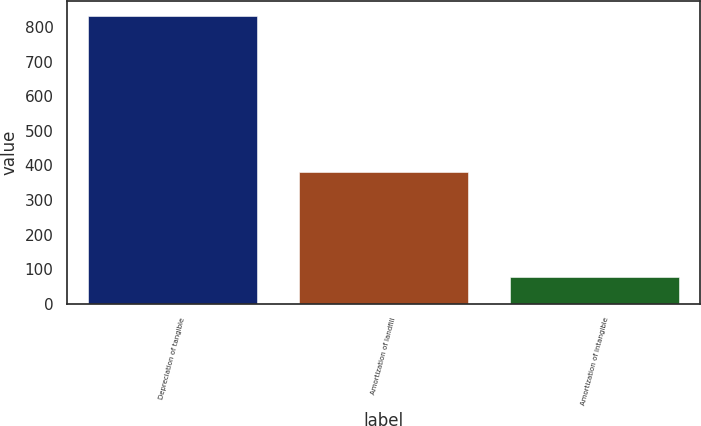Convert chart. <chart><loc_0><loc_0><loc_500><loc_500><bar_chart><fcel>Depreciation of tangible<fcel>Amortization of landfill<fcel>Amortization of intangible<nl><fcel>834<fcel>380<fcel>78<nl></chart> 